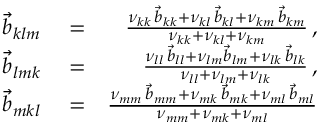<formula> <loc_0><loc_0><loc_500><loc_500>\begin{array} { r l r } { \vec { b } _ { k l m } } & = } & { \frac { \nu _ { k k } \, \vec { b } _ { k k } + \nu _ { k l } \, \vec { b } _ { k l } + \nu _ { k m } \, \vec { b } _ { k m } } { \nu _ { k k } + \nu _ { k l } + \nu _ { k m } } \, , } \\ { \vec { b } _ { l m k } } & = } & { \frac { \nu _ { l l } \, \vec { b } _ { l l } + \nu _ { l m } \vec { b } _ { l m } + \nu _ { l k } \, \vec { b } _ { l k } } { \nu _ { l l } + \nu _ { l m } + \nu _ { l k } } \, , } \\ { \vec { b } _ { m k l } } & = } & { \frac { \nu _ { m m } \, \vec { b } _ { m m } + \nu _ { m k } \, \vec { b } _ { m k } + \nu _ { m l } \, \vec { b } _ { m l } } { \nu _ { m m } + \nu _ { m k } + \nu _ { m l } } } \end{array}</formula> 